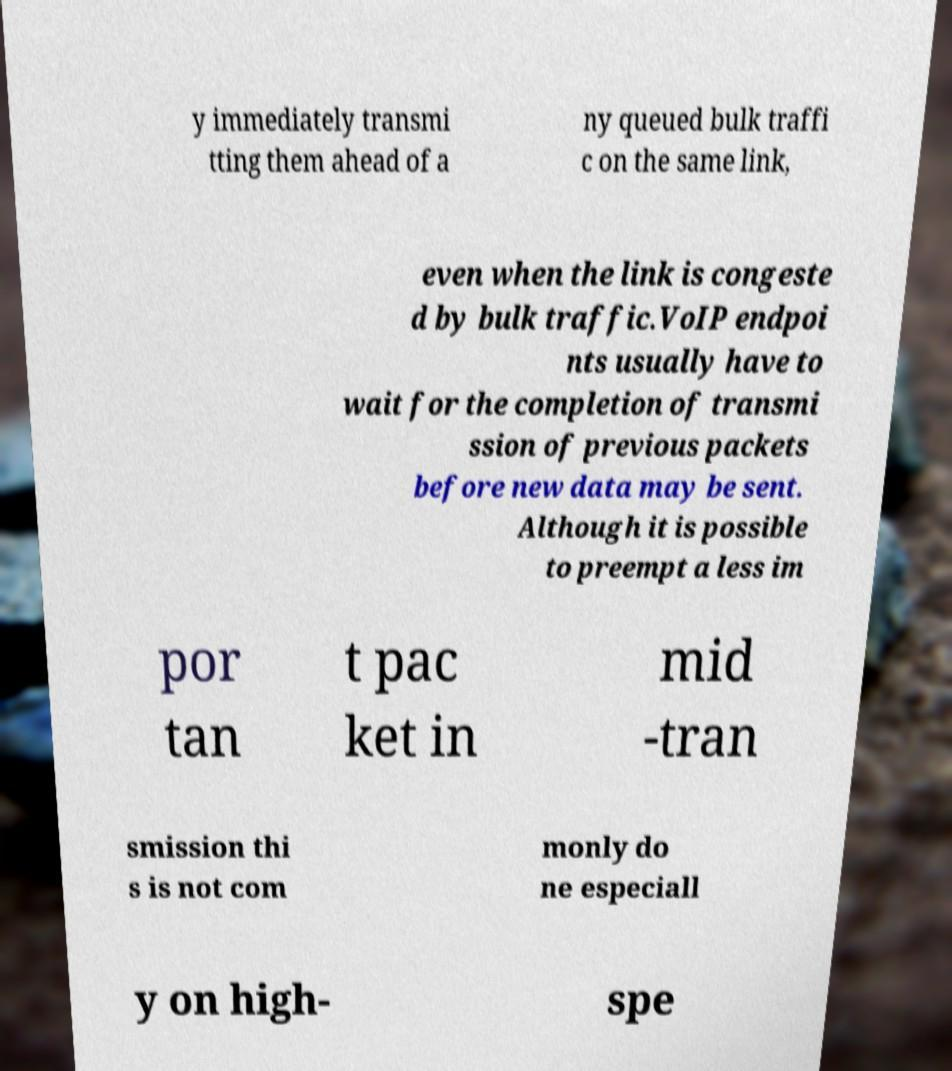What messages or text are displayed in this image? I need them in a readable, typed format. y immediately transmi tting them ahead of a ny queued bulk traffi c on the same link, even when the link is congeste d by bulk traffic.VoIP endpoi nts usually have to wait for the completion of transmi ssion of previous packets before new data may be sent. Although it is possible to preempt a less im por tan t pac ket in mid -tran smission thi s is not com monly do ne especiall y on high- spe 